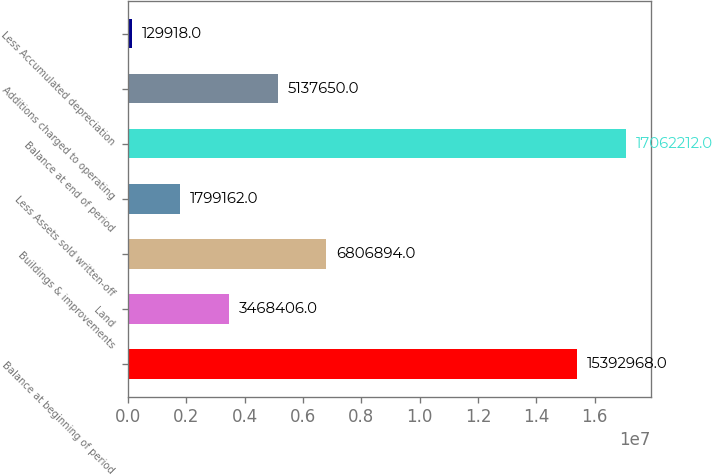<chart> <loc_0><loc_0><loc_500><loc_500><bar_chart><fcel>Balance at beginning of period<fcel>Land<fcel>Buildings & improvements<fcel>Less Assets sold written-off<fcel>Balance at end of period<fcel>Additions charged to operating<fcel>Less Accumulated depreciation<nl><fcel>1.5393e+07<fcel>3.46841e+06<fcel>6.80689e+06<fcel>1.79916e+06<fcel>1.70622e+07<fcel>5.13765e+06<fcel>129918<nl></chart> 